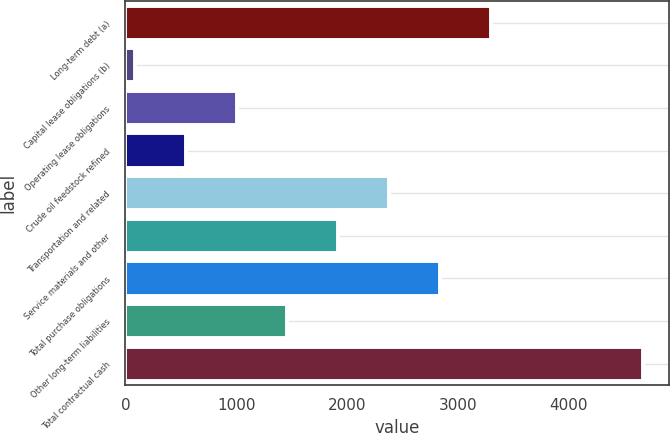Convert chart to OTSL. <chart><loc_0><loc_0><loc_500><loc_500><bar_chart><fcel>Long-term debt (a)<fcel>Capital lease obligations (b)<fcel>Operating lease obligations<fcel>Crude oil feedstock refined<fcel>Transportation and related<fcel>Service materials and other<fcel>Total purchase obligations<fcel>Other long-term liabilities<fcel>Total contractual cash<nl><fcel>3296.1<fcel>88<fcel>1004.6<fcel>546.3<fcel>2379.5<fcel>1921.2<fcel>2837.8<fcel>1462.9<fcel>4671<nl></chart> 